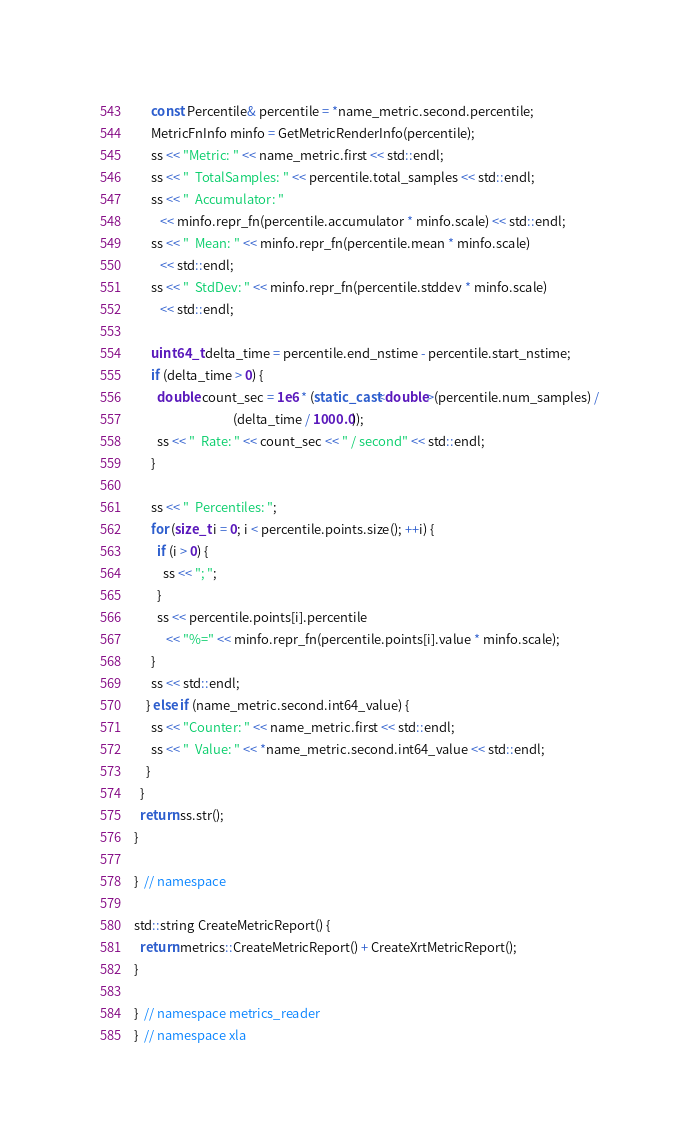Convert code to text. <code><loc_0><loc_0><loc_500><loc_500><_C++_>      const Percentile& percentile = *name_metric.second.percentile;
      MetricFnInfo minfo = GetMetricRenderInfo(percentile);
      ss << "Metric: " << name_metric.first << std::endl;
      ss << "  TotalSamples: " << percentile.total_samples << std::endl;
      ss << "  Accumulator: "
         << minfo.repr_fn(percentile.accumulator * minfo.scale) << std::endl;
      ss << "  Mean: " << minfo.repr_fn(percentile.mean * minfo.scale)
         << std::endl;
      ss << "  StdDev: " << minfo.repr_fn(percentile.stddev * minfo.scale)
         << std::endl;

      uint64_t delta_time = percentile.end_nstime - percentile.start_nstime;
      if (delta_time > 0) {
        double count_sec = 1e6 * (static_cast<double>(percentile.num_samples) /
                                  (delta_time / 1000.0));
        ss << "  Rate: " << count_sec << " / second" << std::endl;
      }

      ss << "  Percentiles: ";
      for (size_t i = 0; i < percentile.points.size(); ++i) {
        if (i > 0) {
          ss << "; ";
        }
        ss << percentile.points[i].percentile
           << "%=" << minfo.repr_fn(percentile.points[i].value * minfo.scale);
      }
      ss << std::endl;
    } else if (name_metric.second.int64_value) {
      ss << "Counter: " << name_metric.first << std::endl;
      ss << "  Value: " << *name_metric.second.int64_value << std::endl;
    }
  }
  return ss.str();
}

}  // namespace

std::string CreateMetricReport() {
  return metrics::CreateMetricReport() + CreateXrtMetricReport();
}

}  // namespace metrics_reader
}  // namespace xla
</code> 